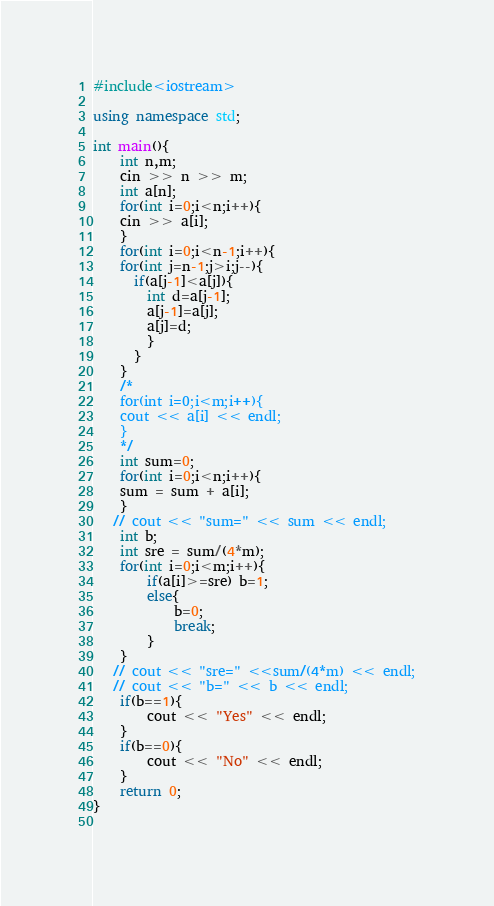Convert code to text. <code><loc_0><loc_0><loc_500><loc_500><_C++_>#include<iostream>

using namespace std;

int main(){
    int n,m;
    cin >> n >> m;
    int a[n];
    for(int i=0;i<n;i++){
    cin >> a[i];
    }
    for(int i=0;i<n-1;i++){
    for(int j=n-1;j>i;j--){
      if(a[j-1]<a[j]){
        int d=a[j-1];
        a[j-1]=a[j];
        a[j]=d;
        }
      }
    }
    /*
    for(int i=0;i<m;i++){
	cout << a[i] << endl;
    } 
    */
    int sum=0;
    for(int i=0;i<n;i++){
	sum = sum + a[i];
    }
   // cout << "sum=" << sum << endl;
    int b;
    int sre = sum/(4*m);
    for(int i=0;i<m;i++){
	    if(a[i]>=sre) b=1;
	    else{
		    b=0;
		    break;
	    }
    }
   // cout << "sre=" <<sum/(4*m) << endl;
   // cout << "b=" << b << endl;
    if(b==1){
	    cout << "Yes" << endl;
    }
    if(b==0){
	    cout << "No" << endl;
    }
    return 0;
}
    
</code> 